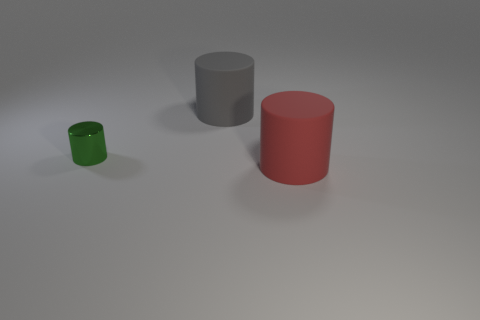There is a matte object behind the green metallic thing; is its size the same as the metal cylinder that is in front of the large gray rubber thing?
Make the answer very short. No. What number of spheres are cyan rubber objects or small green shiny things?
Your answer should be compact. 0. What number of metal objects are gray cylinders or small purple cylinders?
Your response must be concise. 0. What is the size of the green thing that is the same shape as the large red matte object?
Your response must be concise. Small. Is there any other thing that has the same size as the shiny object?
Your answer should be compact. No. There is a green cylinder; is it the same size as the matte thing that is behind the small green object?
Ensure brevity in your answer.  No. The object that is in front of the small metal cylinder has what shape?
Ensure brevity in your answer.  Cylinder. There is a large thing on the left side of the cylinder right of the large gray matte thing; what is its color?
Provide a short and direct response. Gray. What color is the small shiny object that is the same shape as the large red matte object?
Give a very brief answer. Green. There is a thing that is both in front of the big gray rubber cylinder and to the left of the large red cylinder; what is its shape?
Your answer should be very brief. Cylinder. 